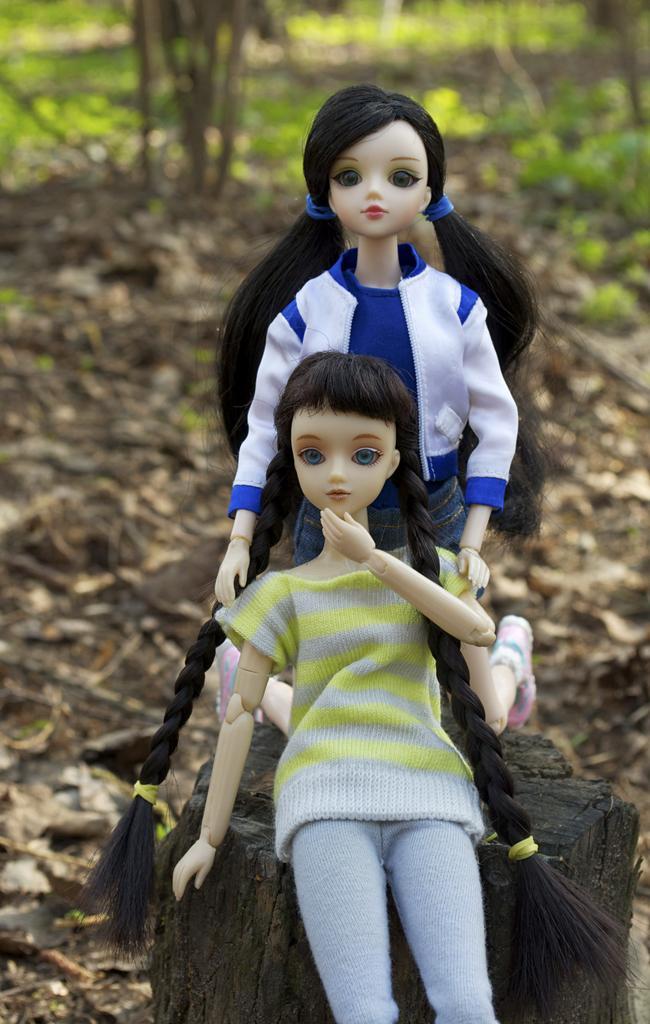Can you describe this image briefly? In the image I can see two dolls on the trunk and behind there are some trees, plants and some dry leaves on the floor. 